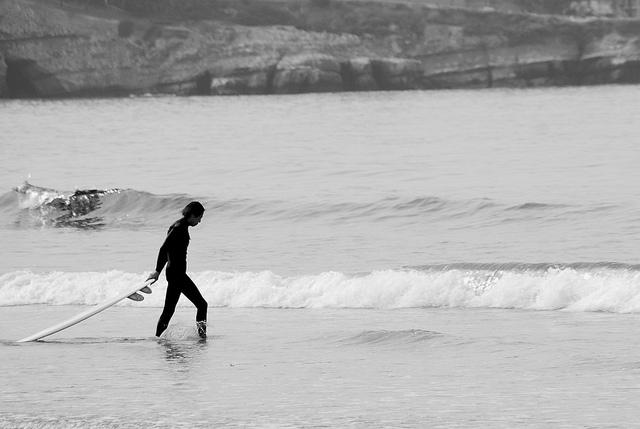How many waves are in the picture?
Short answer required. 2. What activity is the man doing?
Quick response, please. Surfing. Why is the person dragging their board?
Quick response, please. To get to water. What is the woman holding?
Concise answer only. Surfboard. Is the water calm?
Concise answer only. No. What is cast?
Answer briefly. Surfboard. How many people are in the water?
Give a very brief answer. 1. What is the person dragging?
Keep it brief. Surfboard. Is it winter time?
Be succinct. No. Is the snow deep?
Concise answer only. No. Does this female look happy?
Quick response, please. No. Are there trees nearby?
Be succinct. No. What is the man doing?
Quick response, please. Surfing. 